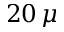Convert formula to latex. <formula><loc_0><loc_0><loc_500><loc_500>2 0 \, \mu</formula> 